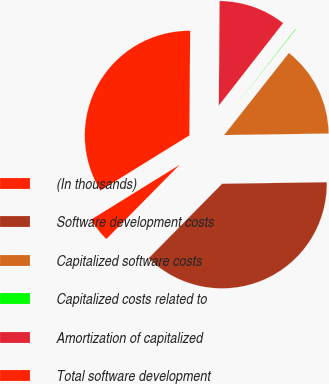<chart> <loc_0><loc_0><loc_500><loc_500><pie_chart><fcel>(In thousands)<fcel>Software development costs<fcel>Capitalized software costs<fcel>Capitalized costs related to<fcel>Amortization of capitalized<fcel>Total software development<nl><fcel>3.79%<fcel>37.62%<fcel>14.13%<fcel>0.09%<fcel>10.43%<fcel>33.93%<nl></chart> 